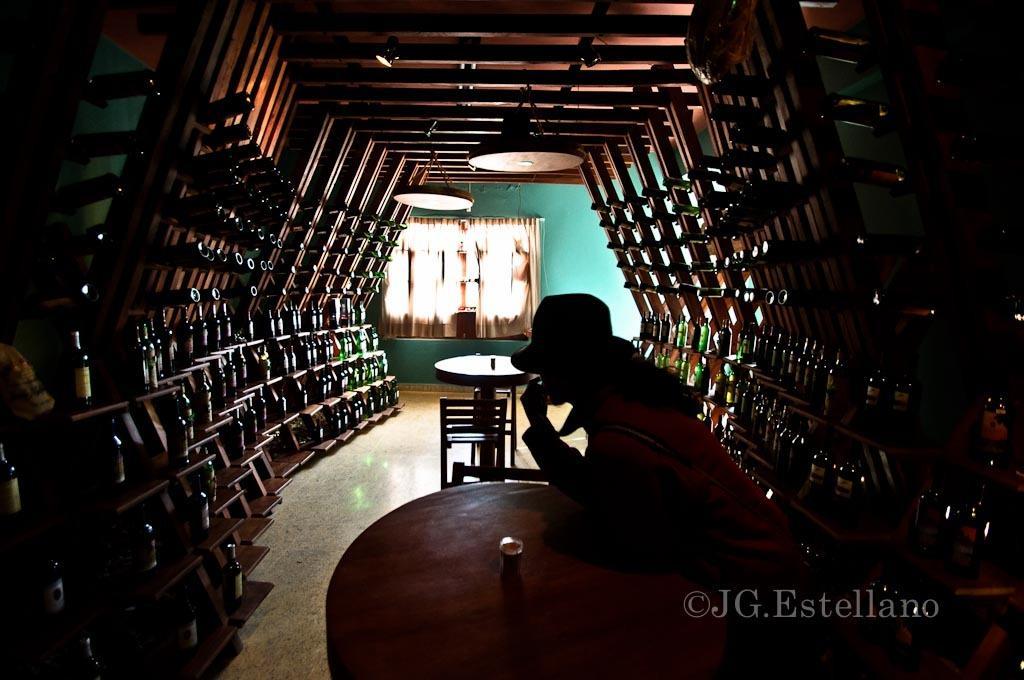How would you summarize this image in a sentence or two? In the center of the image we can see a person is sitting and wearing a hat. In front of a person, there is a table. On the table, we can see one object. At the bottom right side of the image, there is a watermark. On the left and right side of the image, we can see shelves and wine bottles. At the top of the image, we can see some wooden objects. In the background there is a wall, curtain, table and chairs. 